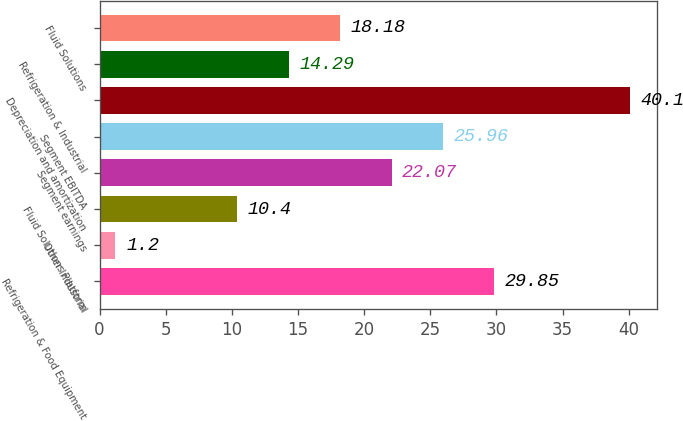Convert chart. <chart><loc_0><loc_0><loc_500><loc_500><bar_chart><fcel>Refrigeration & Food Equipment<fcel>Other Industrial<fcel>Fluid Solutions Platform<fcel>Segment earnings<fcel>Segment EBITDA<fcel>Depreciation and amortization<fcel>Refrigeration & Industrial<fcel>Fluid Solutions<nl><fcel>29.85<fcel>1.2<fcel>10.4<fcel>22.07<fcel>25.96<fcel>40.1<fcel>14.29<fcel>18.18<nl></chart> 